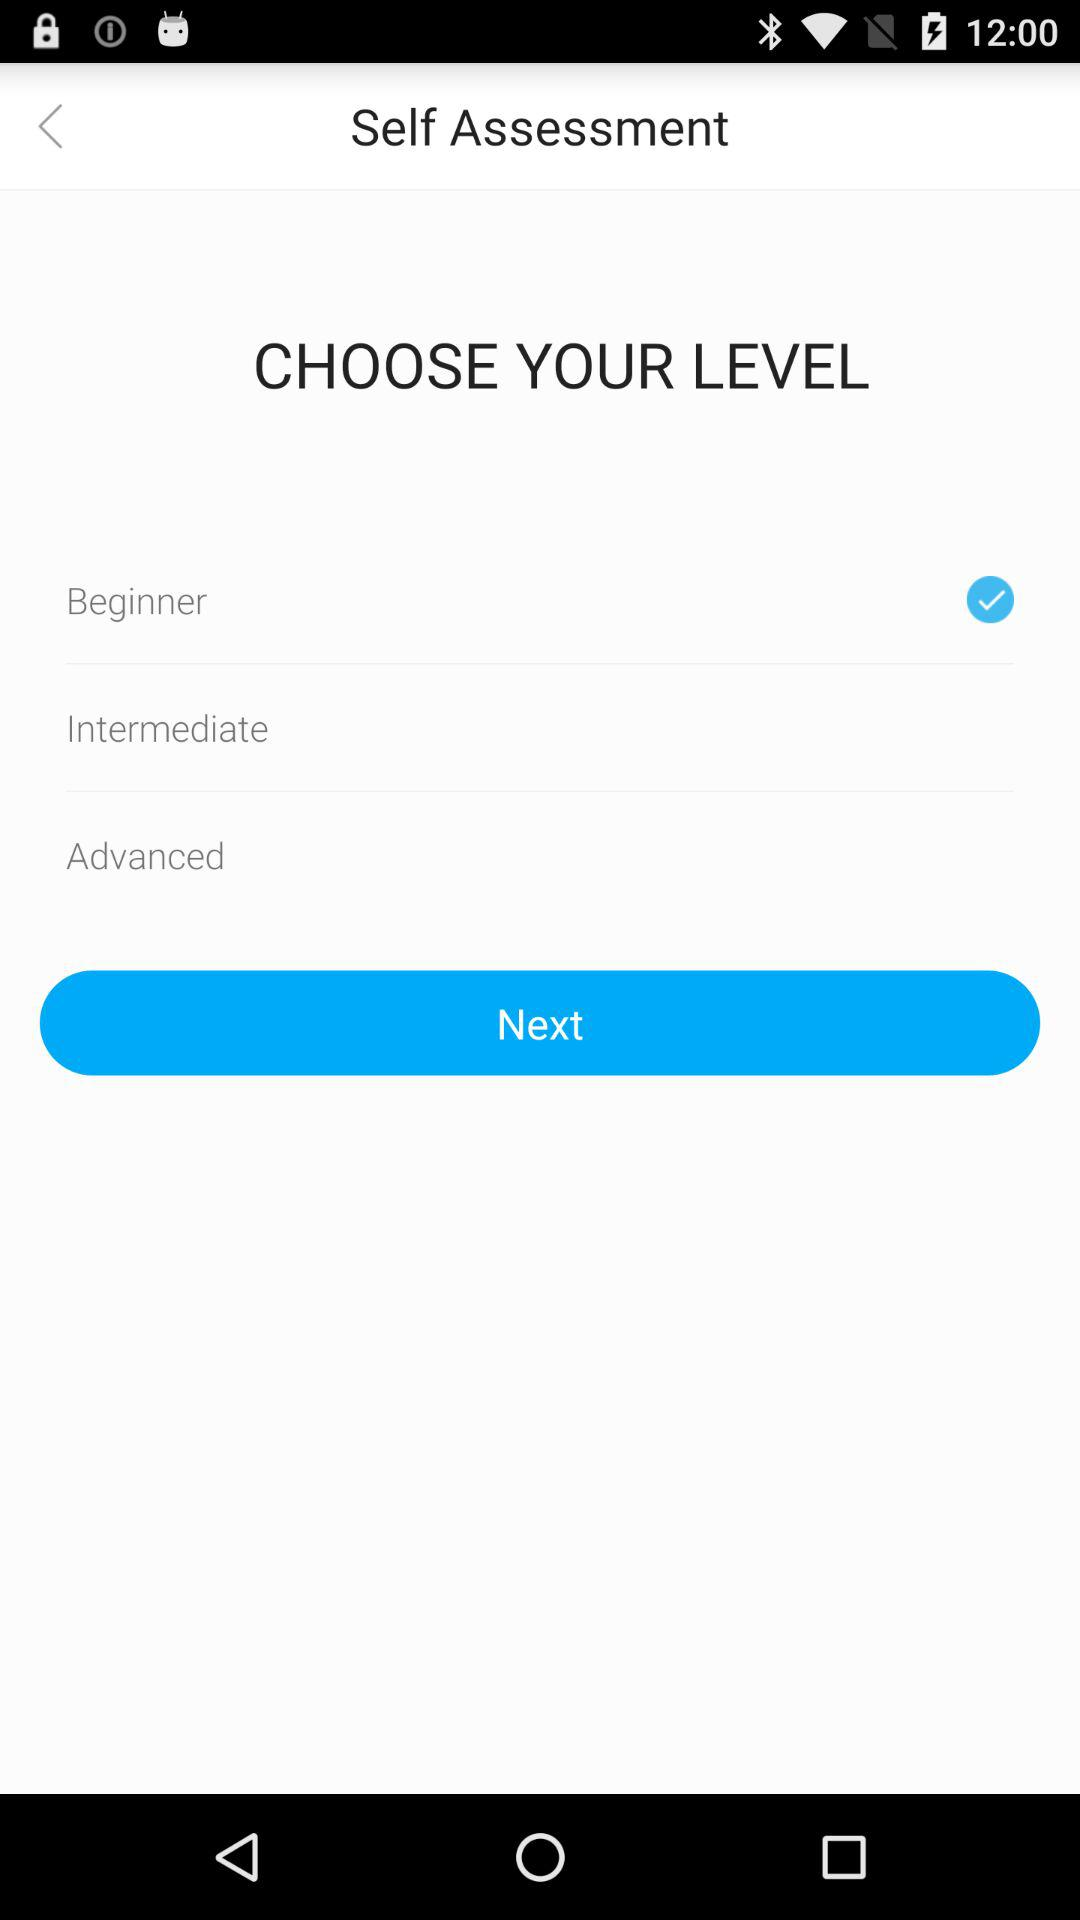Which level is selected? The selected level is "Beginner". 